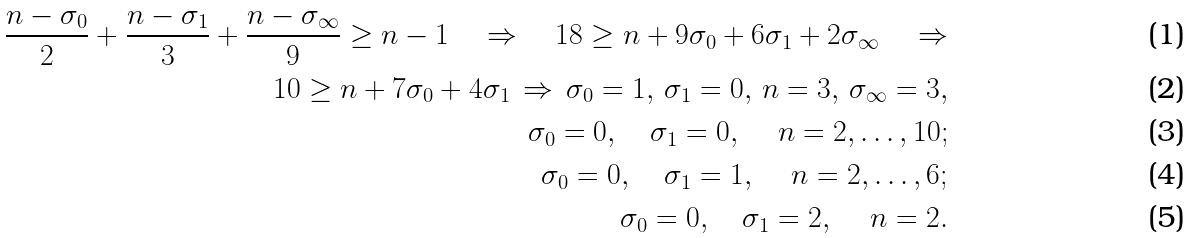Convert formula to latex. <formula><loc_0><loc_0><loc_500><loc_500>\frac { n - \sigma _ { 0 } } 2 + \frac { n - \sigma _ { 1 } } 3 + \frac { n - \sigma _ { \infty } } 9 \geq n - 1 \quad \Rightarrow \quad 1 8 \geq n + 9 \sigma _ { 0 } + 6 \sigma _ { 1 } + 2 \sigma _ { \infty } \quad \Rightarrow \\ 1 0 \geq n + 7 \sigma _ { 0 } + 4 \sigma _ { 1 } \, \Rightarrow \, \sigma _ { 0 } = 1 , \, \sigma _ { 1 } = 0 , \, n = 3 , \, \sigma _ { \infty } = 3 , \\ \sigma _ { 0 } = 0 , \quad \sigma _ { 1 } = 0 , \quad \, n = 2 , \dots , 1 0 ; \\ \sigma _ { 0 } = 0 , \quad \sigma _ { 1 } = 1 , \quad \, n = 2 , \dots , 6 ; \\ \sigma _ { 0 } = 0 , \quad \sigma _ { 1 } = 2 , \quad \, n = 2 .</formula> 